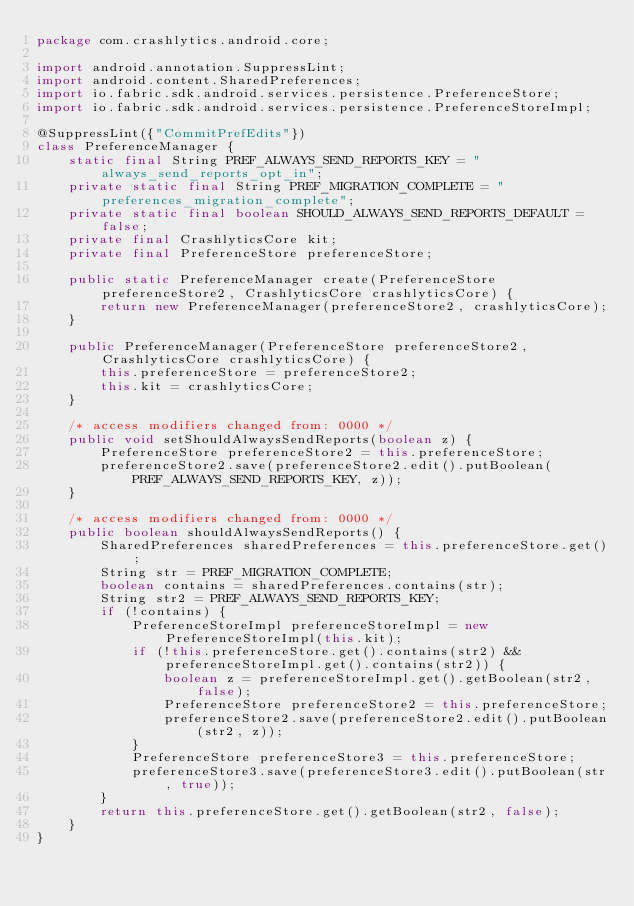<code> <loc_0><loc_0><loc_500><loc_500><_Java_>package com.crashlytics.android.core;

import android.annotation.SuppressLint;
import android.content.SharedPreferences;
import io.fabric.sdk.android.services.persistence.PreferenceStore;
import io.fabric.sdk.android.services.persistence.PreferenceStoreImpl;

@SuppressLint({"CommitPrefEdits"})
class PreferenceManager {
    static final String PREF_ALWAYS_SEND_REPORTS_KEY = "always_send_reports_opt_in";
    private static final String PREF_MIGRATION_COMPLETE = "preferences_migration_complete";
    private static final boolean SHOULD_ALWAYS_SEND_REPORTS_DEFAULT = false;
    private final CrashlyticsCore kit;
    private final PreferenceStore preferenceStore;

    public static PreferenceManager create(PreferenceStore preferenceStore2, CrashlyticsCore crashlyticsCore) {
        return new PreferenceManager(preferenceStore2, crashlyticsCore);
    }

    public PreferenceManager(PreferenceStore preferenceStore2, CrashlyticsCore crashlyticsCore) {
        this.preferenceStore = preferenceStore2;
        this.kit = crashlyticsCore;
    }

    /* access modifiers changed from: 0000 */
    public void setShouldAlwaysSendReports(boolean z) {
        PreferenceStore preferenceStore2 = this.preferenceStore;
        preferenceStore2.save(preferenceStore2.edit().putBoolean(PREF_ALWAYS_SEND_REPORTS_KEY, z));
    }

    /* access modifiers changed from: 0000 */
    public boolean shouldAlwaysSendReports() {
        SharedPreferences sharedPreferences = this.preferenceStore.get();
        String str = PREF_MIGRATION_COMPLETE;
        boolean contains = sharedPreferences.contains(str);
        String str2 = PREF_ALWAYS_SEND_REPORTS_KEY;
        if (!contains) {
            PreferenceStoreImpl preferenceStoreImpl = new PreferenceStoreImpl(this.kit);
            if (!this.preferenceStore.get().contains(str2) && preferenceStoreImpl.get().contains(str2)) {
                boolean z = preferenceStoreImpl.get().getBoolean(str2, false);
                PreferenceStore preferenceStore2 = this.preferenceStore;
                preferenceStore2.save(preferenceStore2.edit().putBoolean(str2, z));
            }
            PreferenceStore preferenceStore3 = this.preferenceStore;
            preferenceStore3.save(preferenceStore3.edit().putBoolean(str, true));
        }
        return this.preferenceStore.get().getBoolean(str2, false);
    }
}
</code> 